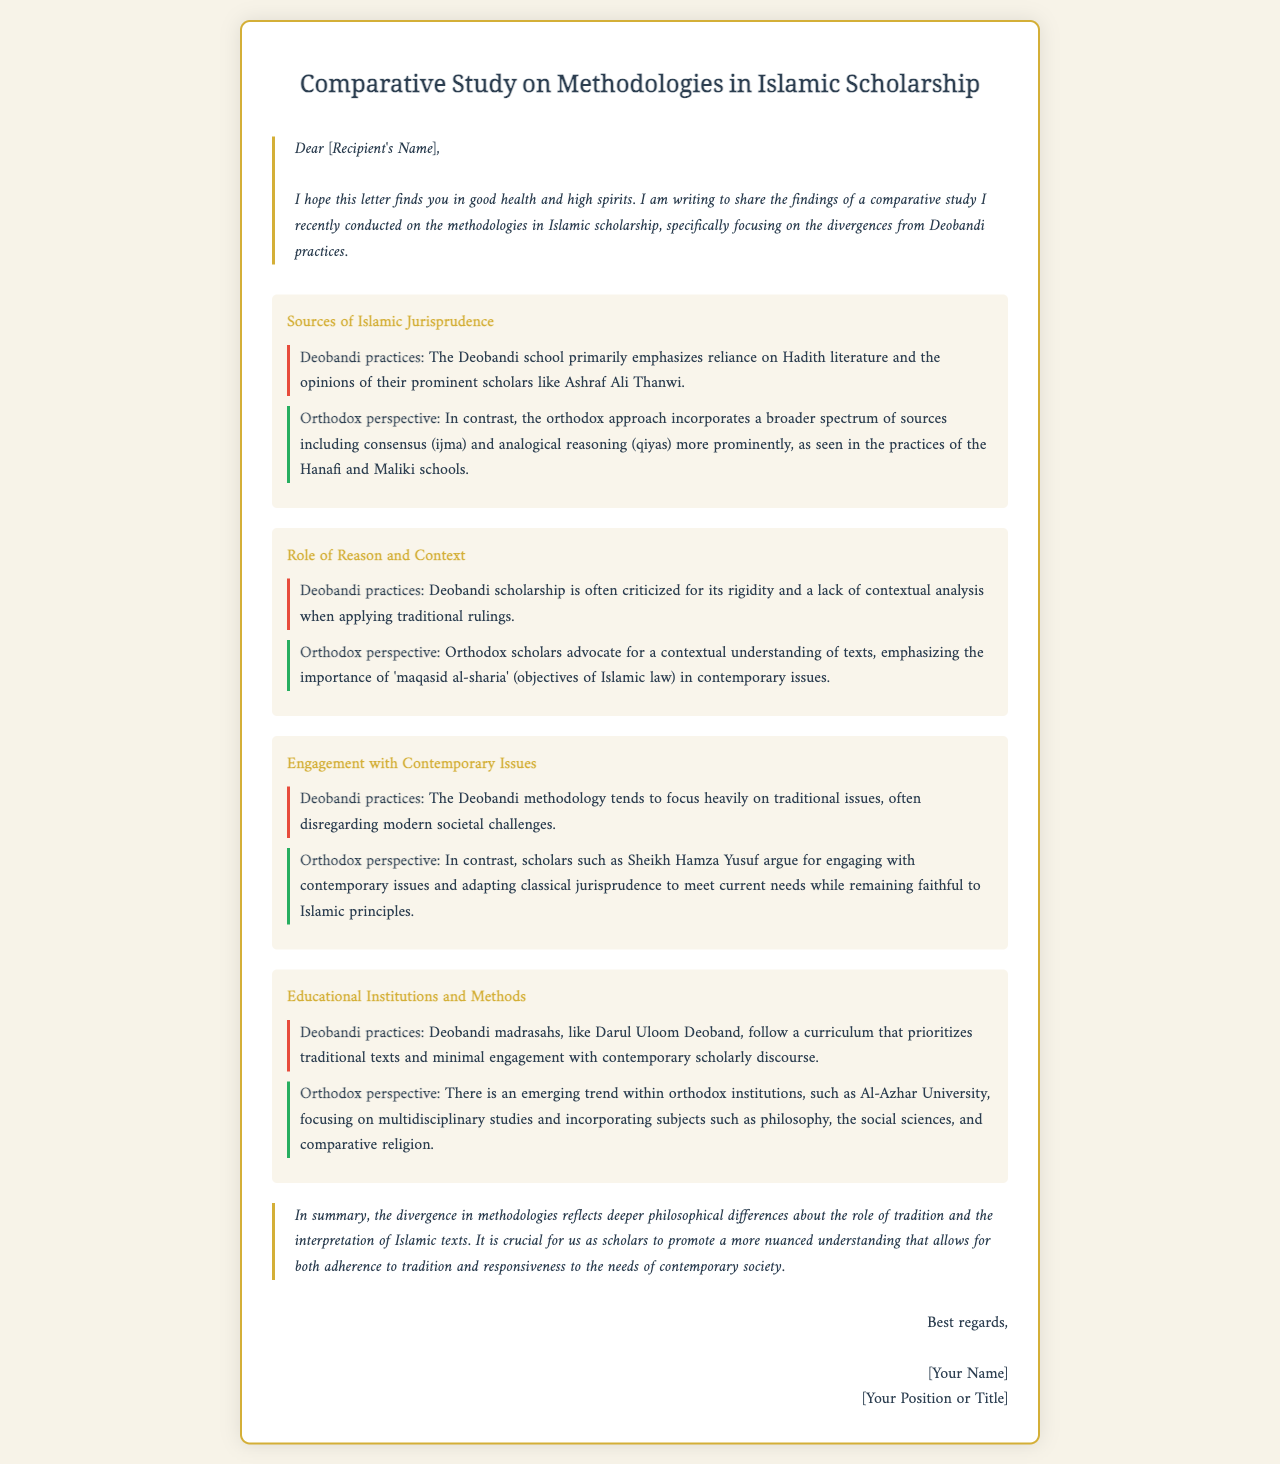What is the main topic of the letter? The letter addresses a comparative study on methodologies in Islamic scholarship, specifically focusing on divergences from Deobandi practices.
Answer: Methodologies in Islamic scholarship Who is the intended recipient of the letter? The letter is addressed to a person referred to as "[Recipient's Name]" indicating an individual recipient.
Answer: [Recipient's Name] What is emphasized in Deobandi practices regarding sources of jurisprudence? Deobandi practices emphasize reliance on Hadith literature and opinions of prominent scholars like Ashraf Ali Thanwi.
Answer: Reliance on Hadith literature What does the orthodox perspective advocate for concerning the role of reason? The orthodox perspective emphasizes a contextual understanding of texts and the importance of 'maqasid al-sharia'.
Answer: Contextual understanding Which institution is mentioned as a representative of Orthodox education? Al-Azhar University is noted for its focus on multidisciplinary studies within the orthodox perspective.
Answer: Al-Azhar University What criticism is mentioned regarding Deobandi scholarship? Deobandi scholarship is criticized for its rigidity and lack of contextual analysis in applying traditional rulings.
Answer: Rigidity and lack of contextual analysis What aspect of contemporary issues is highlighted in the orthodox perspective? The orthodox perspective argues for engaging with contemporary issues and adapting classical jurisprudence to meet current needs.
Answer: Engaging with contemporary issues In the conclusion, what is highlighted as essential for scholars? The conclusion emphasizes promoting a nuanced understanding that balances tradition with contemporary needs.
Answer: Promote a nuanced understanding 